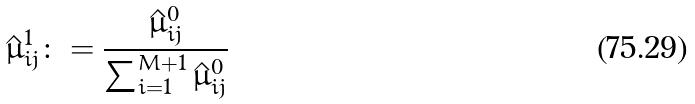<formula> <loc_0><loc_0><loc_500><loc_500>\hat { \mu } _ { i j } ^ { 1 } \colon = \frac { \hat { \mu } _ { i j } ^ { 0 } } { \sum _ { i = 1 } ^ { M + 1 } \hat { \mu } _ { i j } ^ { 0 } }</formula> 